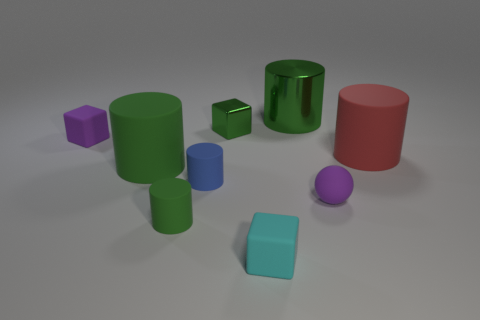Are there any other things that have the same color as the tiny metal thing?
Ensure brevity in your answer.  Yes. There is a small rubber cube behind the cyan rubber cube; is it the same color as the large metal object?
Your answer should be very brief. No. Does the tiny ball have the same color as the large cylinder that is on the left side of the large metal object?
Offer a terse response. No. Are there more blue matte cylinders than large brown metal balls?
Offer a very short reply. Yes. Is the shape of the small purple rubber thing right of the blue rubber cylinder the same as  the big metallic thing?
Ensure brevity in your answer.  No. How many metal things are things or big brown objects?
Ensure brevity in your answer.  2. Is there a tiny purple ball that has the same material as the large red object?
Keep it short and to the point. Yes. What is the small purple block made of?
Your answer should be very brief. Rubber. What shape is the big green thing in front of the tiny green object that is behind the cube to the left of the green block?
Your answer should be compact. Cylinder. Are there more things that are to the left of the small purple cube than brown metallic cubes?
Provide a short and direct response. No. 